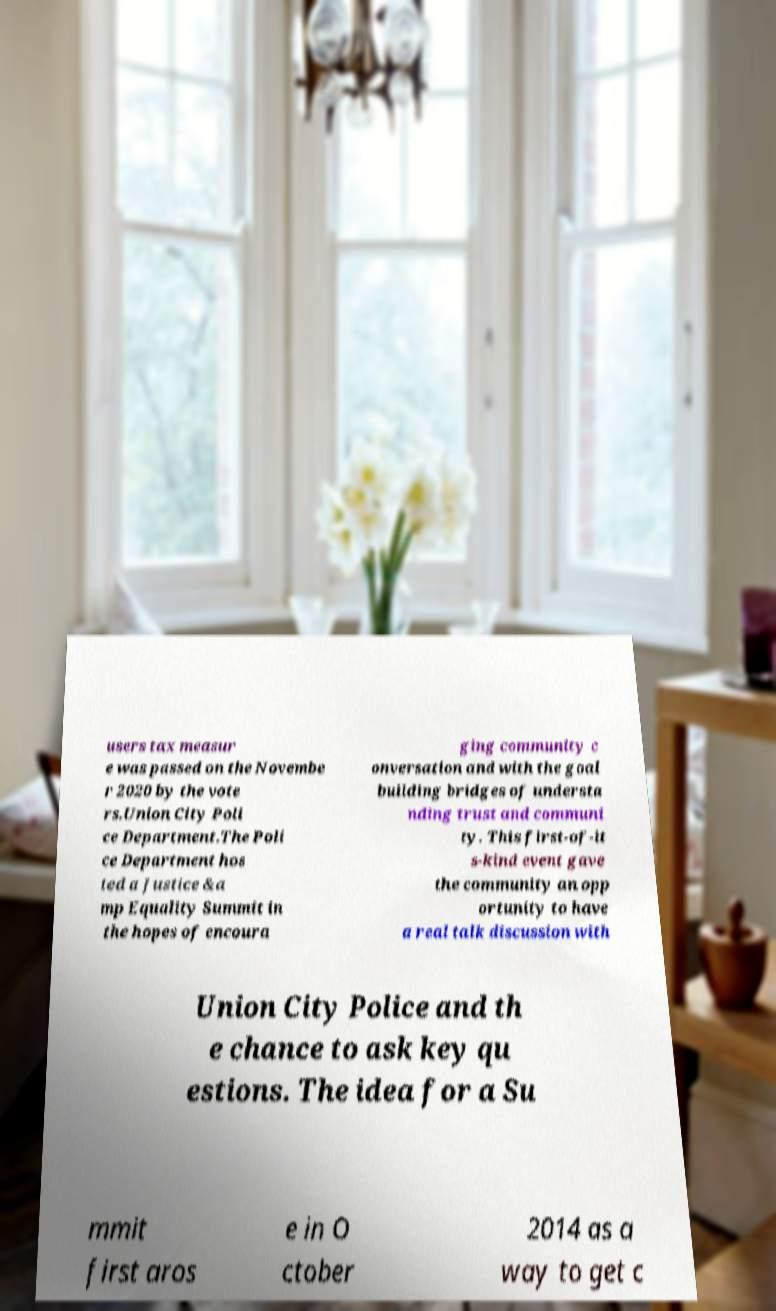Please identify and transcribe the text found in this image. users tax measur e was passed on the Novembe r 2020 by the vote rs.Union City Poli ce Department.The Poli ce Department hos ted a Justice &a mp Equality Summit in the hopes of encoura ging community c onversation and with the goal building bridges of understa nding trust and communi ty. This first-of-it s-kind event gave the community an opp ortunity to have a real talk discussion with Union City Police and th e chance to ask key qu estions. The idea for a Su mmit first aros e in O ctober 2014 as a way to get c 